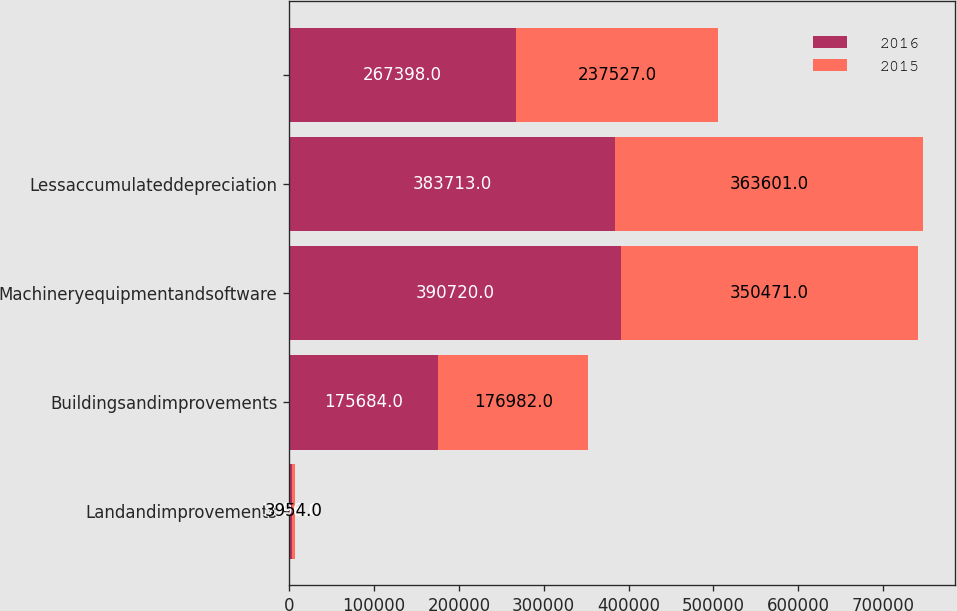<chart> <loc_0><loc_0><loc_500><loc_500><stacked_bar_chart><ecel><fcel>Landandimprovements<fcel>Buildingsandimprovements<fcel>Machineryequipmentandsoftware<fcel>Lessaccumulateddepreciation<fcel>Unnamed: 5<nl><fcel>2016<fcel>3096<fcel>175684<fcel>390720<fcel>383713<fcel>267398<nl><fcel>2015<fcel>3954<fcel>176982<fcel>350471<fcel>363601<fcel>237527<nl></chart> 